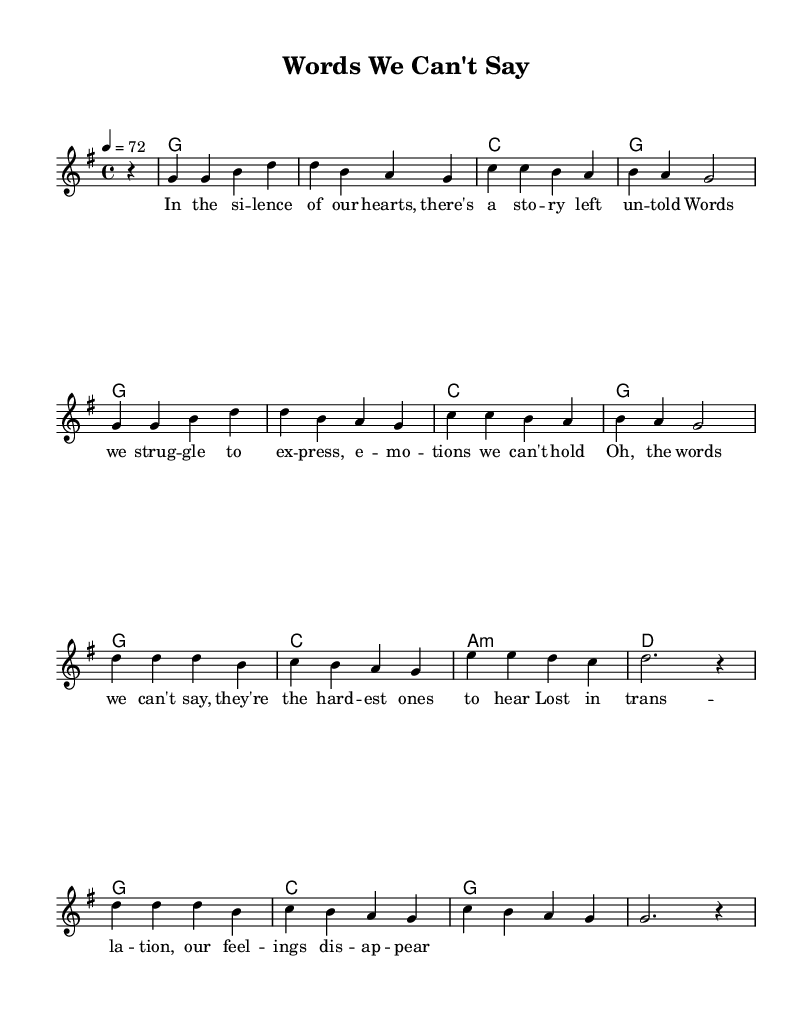What is the key signature of this music? The key signature is indicated by the first symbol shown in the music sheet, which in this case is one sharp, reflecting that it is in G major.
Answer: G major What is the time signature of this music? The time signature is displayed at the beginning of the staff, showing 4/4 time, which means there are four beats in each measure.
Answer: 4/4 What is the tempo marking in this music? The tempo is indicated above the staff in the form of a metronome marking, which states “4 = 72,” meaning the quarter note gets a beat of 72.
Answer: 72 How many measures are in the melody? Counting the sections of melody as indicated by the bar lines, there are a total of 8 measures present in the melody part.
Answer: 8 What is the first lyric line in the verse? The lyrics are set below the melody, and the first line starts with "In the silence of our hearts." This can be found just under the music notes of the first measure.
Answer: In the silence of our hearts Which chords are used in the first two measures? The chord changes are shown above the melody. In the first two measures, the chords used are G and G.
Answer: G, G What emotion is explored in this ballad according to the lyric? The lyrics suggest themes of struggle and unexpressed emotions, indicating the emotional depth in communication challenges within relationships.
Answer: Challenge 